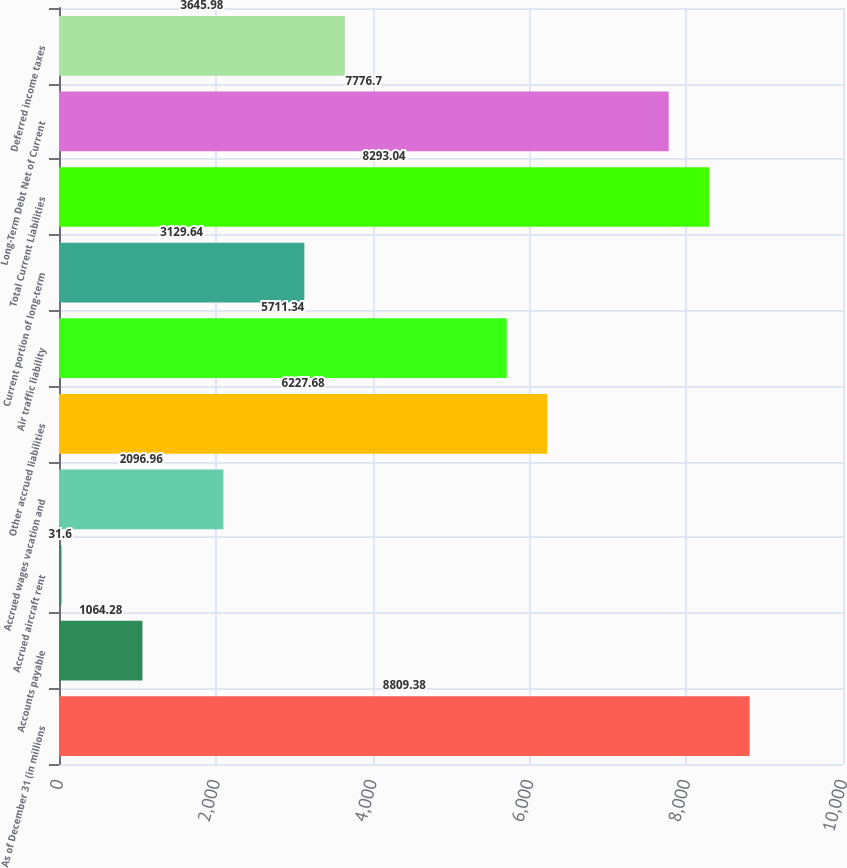<chart> <loc_0><loc_0><loc_500><loc_500><bar_chart><fcel>As of December 31 (in millions<fcel>Accounts payable<fcel>Accrued aircraft rent<fcel>Accrued wages vacation and<fcel>Other accrued liabilities<fcel>Air traffic liability<fcel>Current portion of long-term<fcel>Total Current Liabilities<fcel>Long-Term Debt Net of Current<fcel>Deferred income taxes<nl><fcel>8809.38<fcel>1064.28<fcel>31.6<fcel>2096.96<fcel>6227.68<fcel>5711.34<fcel>3129.64<fcel>8293.04<fcel>7776.7<fcel>3645.98<nl></chart> 